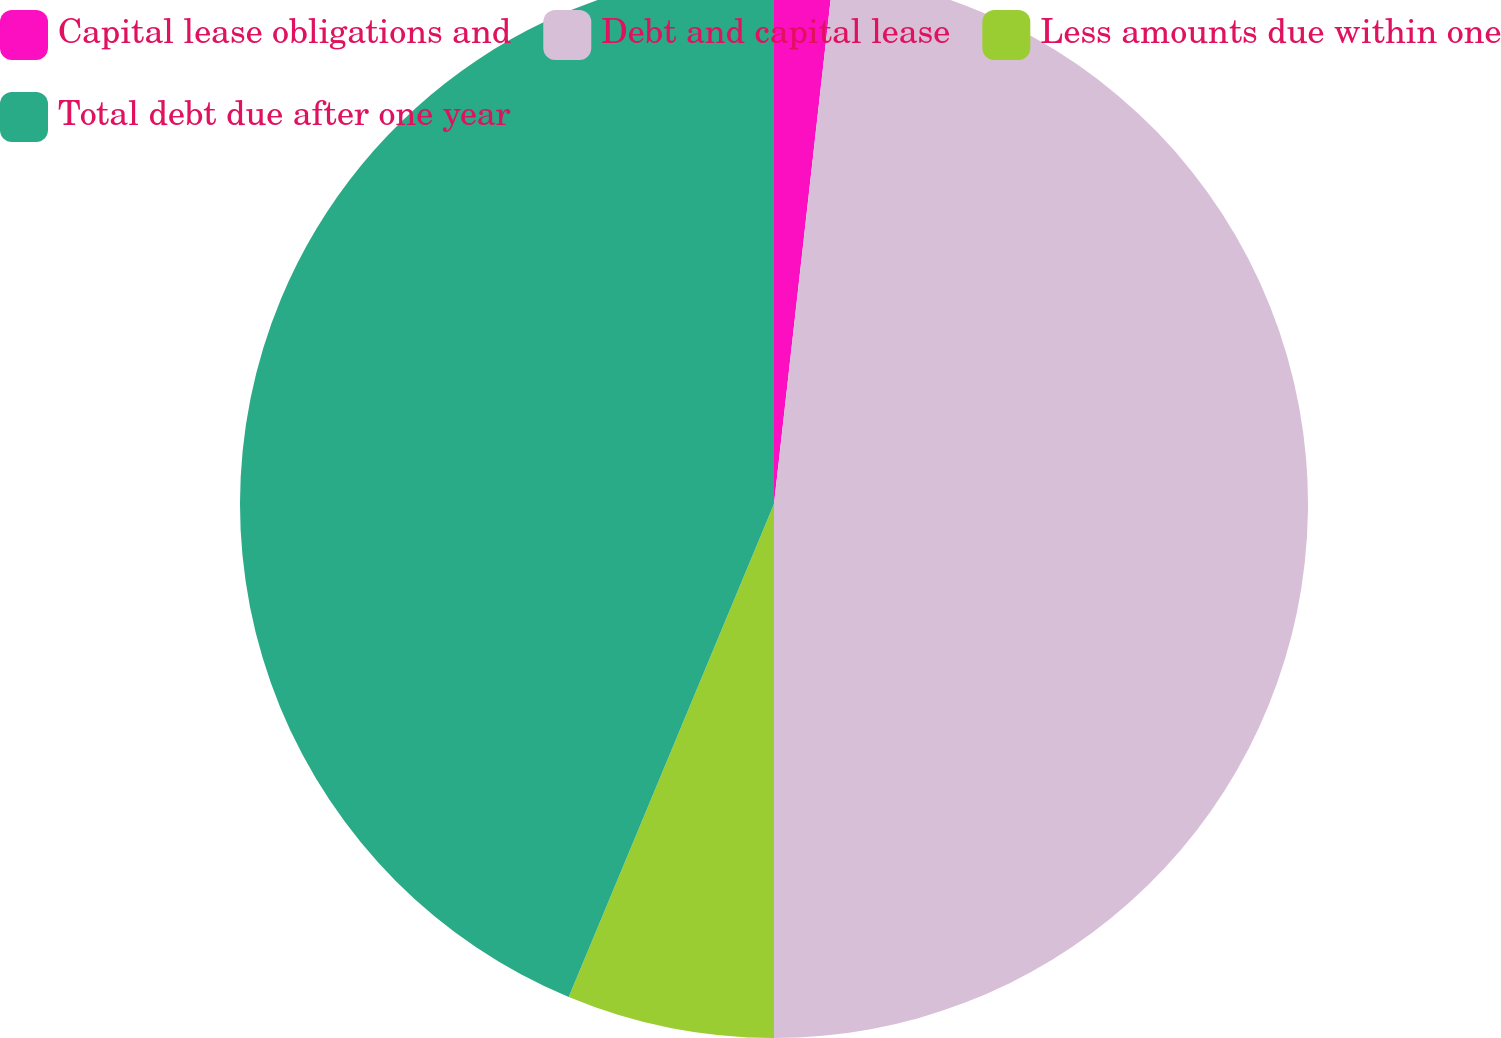<chart> <loc_0><loc_0><loc_500><loc_500><pie_chart><fcel>Capital lease obligations and<fcel>Debt and capital lease<fcel>Less amounts due within one<fcel>Total debt due after one year<nl><fcel>1.78%<fcel>48.22%<fcel>6.28%<fcel>43.72%<nl></chart> 